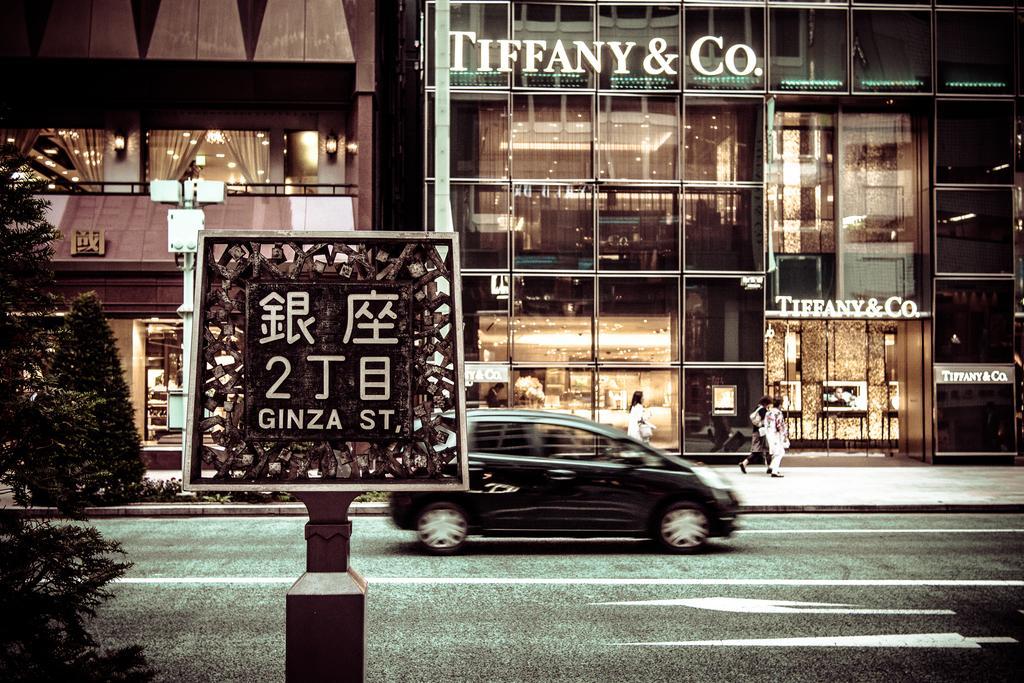In one or two sentences, can you explain what this image depicts? In the image in the center, we can see one car on the road. And we can see one sign board, trees, buildings, lights, few people etc. 